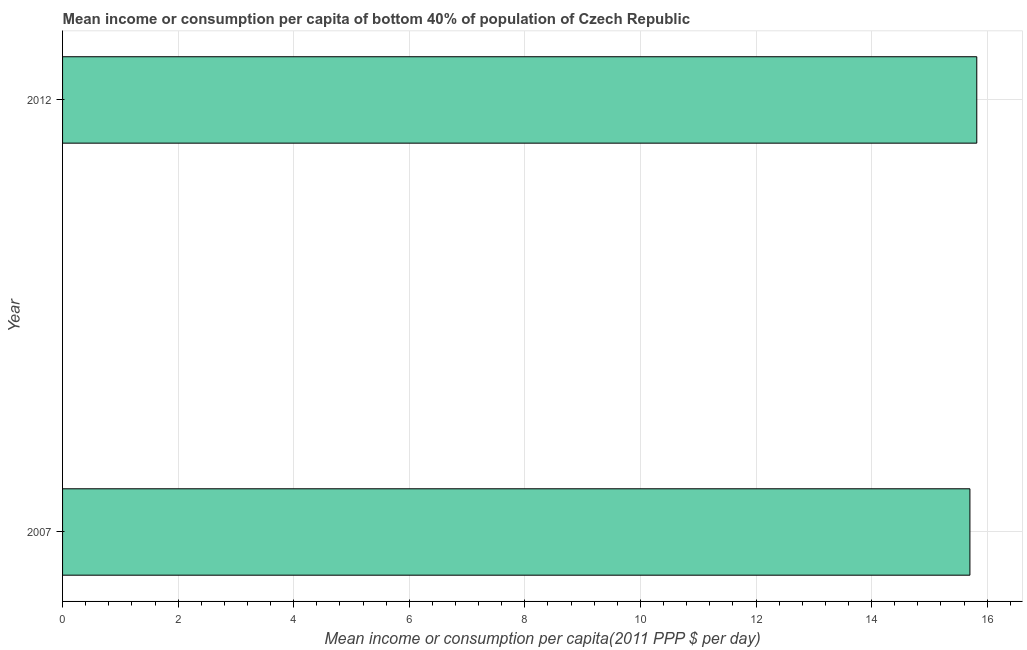Does the graph contain any zero values?
Your answer should be very brief. No. Does the graph contain grids?
Provide a succinct answer. Yes. What is the title of the graph?
Offer a very short reply. Mean income or consumption per capita of bottom 40% of population of Czech Republic. What is the label or title of the X-axis?
Ensure brevity in your answer.  Mean income or consumption per capita(2011 PPP $ per day). What is the label or title of the Y-axis?
Give a very brief answer. Year. What is the mean income or consumption in 2012?
Your answer should be very brief. 15.82. Across all years, what is the maximum mean income or consumption?
Give a very brief answer. 15.82. Across all years, what is the minimum mean income or consumption?
Provide a short and direct response. 15.7. In which year was the mean income or consumption minimum?
Your response must be concise. 2007. What is the sum of the mean income or consumption?
Give a very brief answer. 31.52. What is the difference between the mean income or consumption in 2007 and 2012?
Your response must be concise. -0.12. What is the average mean income or consumption per year?
Give a very brief answer. 15.76. What is the median mean income or consumption?
Offer a very short reply. 15.76. What is the ratio of the mean income or consumption in 2007 to that in 2012?
Make the answer very short. 0.99. In how many years, is the mean income or consumption greater than the average mean income or consumption taken over all years?
Provide a short and direct response. 1. How many bars are there?
Give a very brief answer. 2. How many years are there in the graph?
Ensure brevity in your answer.  2. Are the values on the major ticks of X-axis written in scientific E-notation?
Keep it short and to the point. No. What is the Mean income or consumption per capita(2011 PPP $ per day) of 2007?
Provide a succinct answer. 15.7. What is the Mean income or consumption per capita(2011 PPP $ per day) in 2012?
Provide a short and direct response. 15.82. What is the difference between the Mean income or consumption per capita(2011 PPP $ per day) in 2007 and 2012?
Ensure brevity in your answer.  -0.12. 